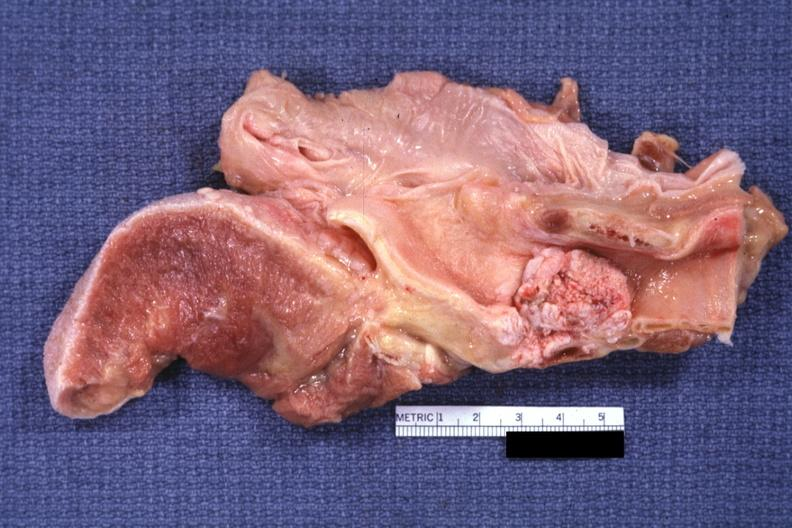what is present?
Answer the question using a single word or phrase. Carcinoma 